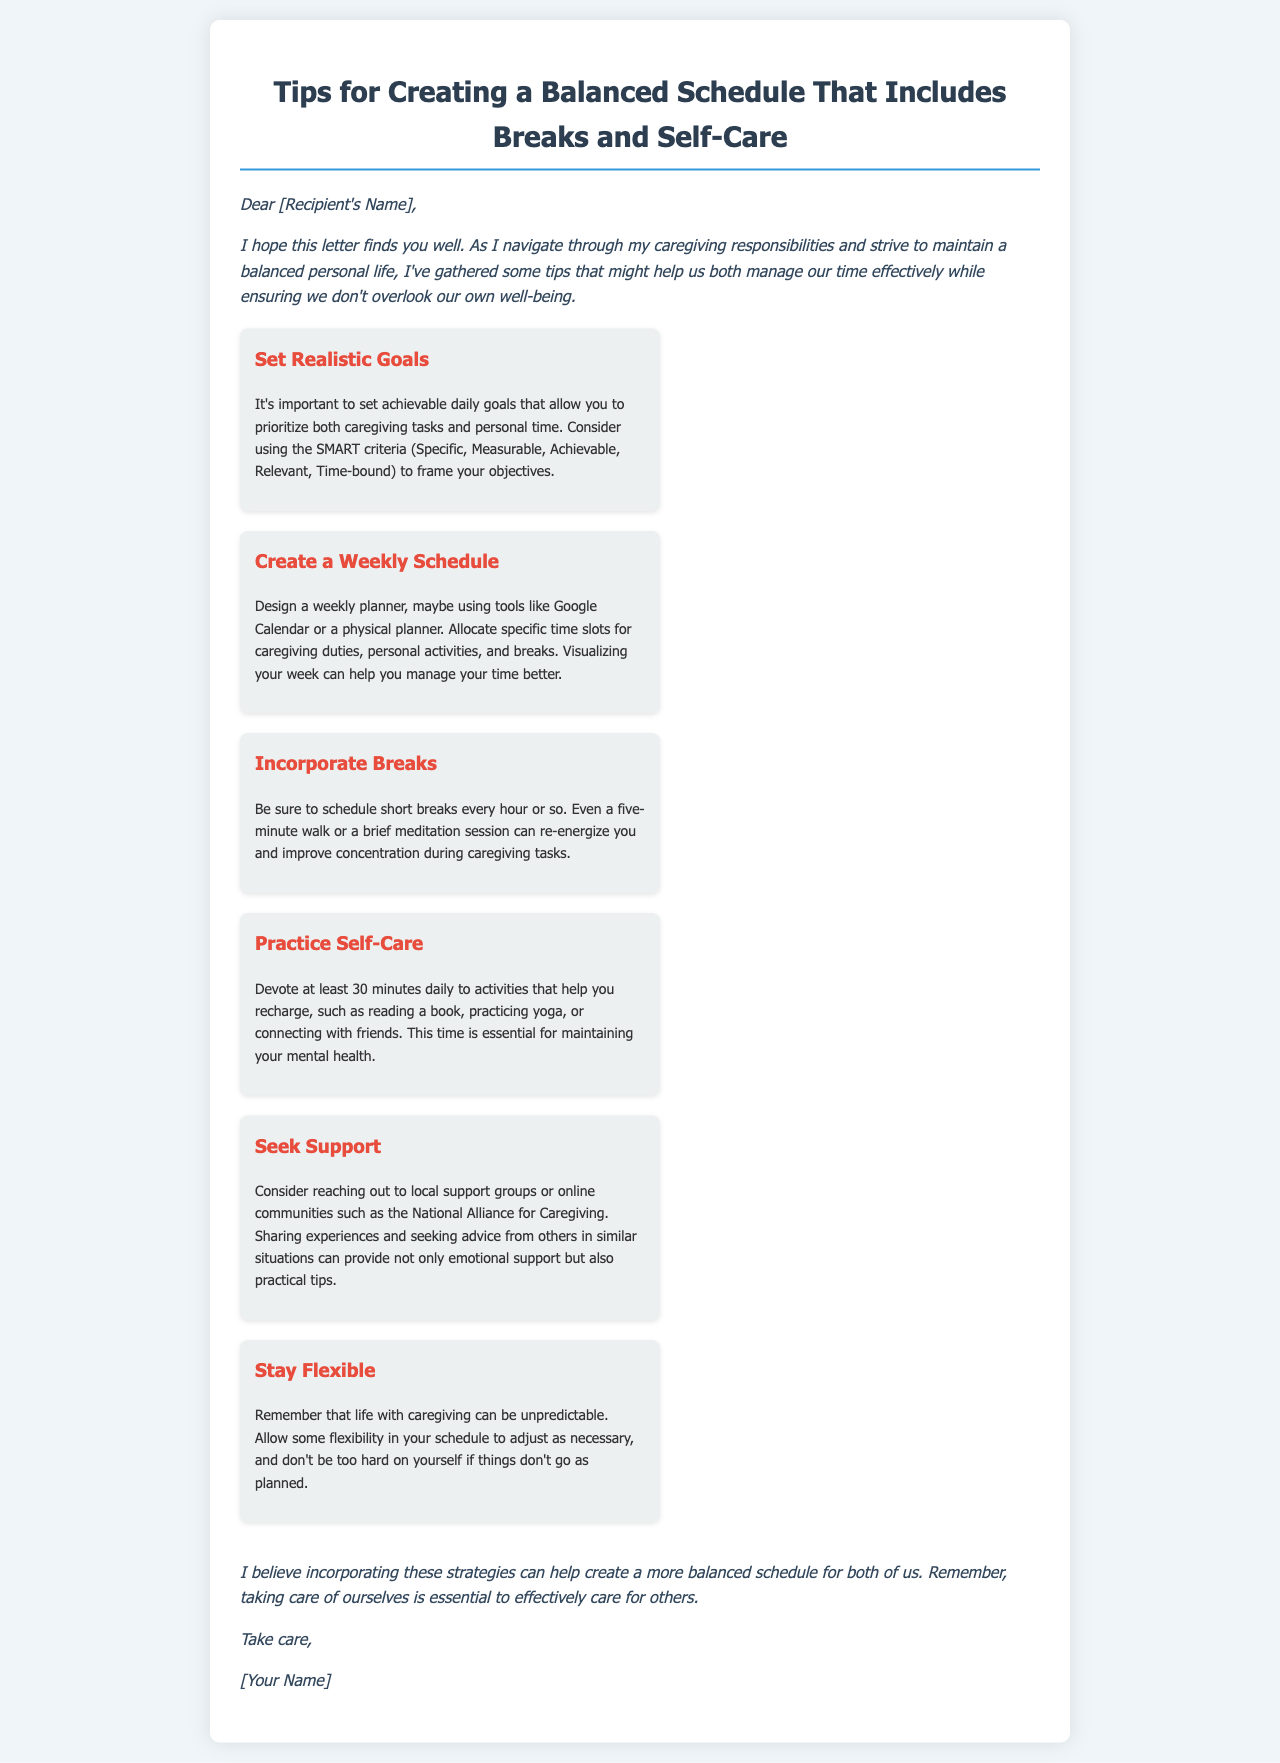What is the title of the letter? The title of the letter is stated at the top of the document.
Answer: Tips for Creating a Balanced Schedule That Includes Breaks and Self-Care How many tips are provided in the letter? The letter lists several strategies to help balance caregiving and personal life, which can be counted in the tips section.
Answer: 6 What is the first tip mentioned in the letter? The first tip in the list is provided under the tips section.
Answer: Set Realistic Goals How long should you devote daily to self-care activities? The advice on self-care includes a specific time allocation.
Answer: 30 minutes What tool is suggested for creating a weekly schedule? The letter mentions tools that can aid in creating a schedule.
Answer: Google Calendar What is recommended to do every hour? The letter suggests a specific action to maintain productivity after a set period of time.
Answer: Schedule short breaks Name one activity that falls under self-care. The letter provides examples of activities that can be considered self-care.
Answer: Reading a book What should you do if your schedule doesn't go as planned? This advice is found towards the end of the tips section, suggesting an approach to unexpected events.
Answer: Stay flexible Who is the audience of this letter? The opening of the document identifies whom the letter is addressing.
Answer: [Recipient's Name] 